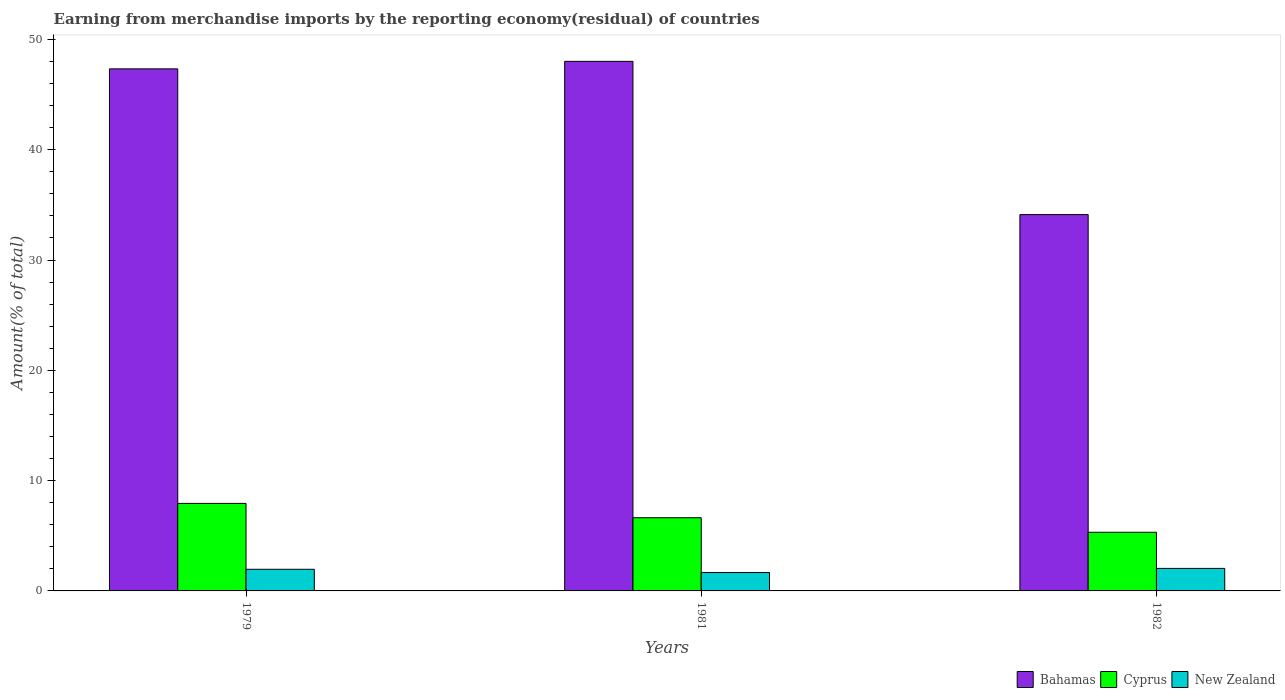How many different coloured bars are there?
Keep it short and to the point. 3. How many groups of bars are there?
Give a very brief answer. 3. How many bars are there on the 3rd tick from the left?
Your answer should be compact. 3. In how many cases, is the number of bars for a given year not equal to the number of legend labels?
Provide a short and direct response. 0. What is the percentage of amount earned from merchandise imports in Cyprus in 1979?
Offer a very short reply. 7.94. Across all years, what is the maximum percentage of amount earned from merchandise imports in Cyprus?
Keep it short and to the point. 7.94. Across all years, what is the minimum percentage of amount earned from merchandise imports in Cyprus?
Your answer should be compact. 5.32. In which year was the percentage of amount earned from merchandise imports in New Zealand maximum?
Offer a very short reply. 1982. What is the total percentage of amount earned from merchandise imports in New Zealand in the graph?
Offer a terse response. 5.67. What is the difference between the percentage of amount earned from merchandise imports in Cyprus in 1979 and that in 1981?
Your answer should be compact. 1.3. What is the difference between the percentage of amount earned from merchandise imports in New Zealand in 1981 and the percentage of amount earned from merchandise imports in Bahamas in 1979?
Your answer should be compact. -45.66. What is the average percentage of amount earned from merchandise imports in Bahamas per year?
Keep it short and to the point. 43.15. In the year 1982, what is the difference between the percentage of amount earned from merchandise imports in Cyprus and percentage of amount earned from merchandise imports in Bahamas?
Offer a very short reply. -28.8. What is the ratio of the percentage of amount earned from merchandise imports in New Zealand in 1979 to that in 1982?
Provide a short and direct response. 0.96. Is the difference between the percentage of amount earned from merchandise imports in Cyprus in 1981 and 1982 greater than the difference between the percentage of amount earned from merchandise imports in Bahamas in 1981 and 1982?
Give a very brief answer. No. What is the difference between the highest and the second highest percentage of amount earned from merchandise imports in New Zealand?
Your answer should be very brief. 0.08. What is the difference between the highest and the lowest percentage of amount earned from merchandise imports in New Zealand?
Make the answer very short. 0.37. In how many years, is the percentage of amount earned from merchandise imports in Bahamas greater than the average percentage of amount earned from merchandise imports in Bahamas taken over all years?
Your answer should be very brief. 2. Is the sum of the percentage of amount earned from merchandise imports in Cyprus in 1979 and 1981 greater than the maximum percentage of amount earned from merchandise imports in New Zealand across all years?
Ensure brevity in your answer.  Yes. What does the 1st bar from the left in 1979 represents?
Offer a terse response. Bahamas. What does the 1st bar from the right in 1982 represents?
Provide a succinct answer. New Zealand. Is it the case that in every year, the sum of the percentage of amount earned from merchandise imports in Cyprus and percentage of amount earned from merchandise imports in Bahamas is greater than the percentage of amount earned from merchandise imports in New Zealand?
Give a very brief answer. Yes. Are all the bars in the graph horizontal?
Your answer should be compact. No. What is the difference between two consecutive major ticks on the Y-axis?
Give a very brief answer. 10. Does the graph contain any zero values?
Give a very brief answer. No. Does the graph contain grids?
Your answer should be compact. No. How are the legend labels stacked?
Your response must be concise. Horizontal. What is the title of the graph?
Offer a very short reply. Earning from merchandise imports by the reporting economy(residual) of countries. Does "Middle East & North Africa (all income levels)" appear as one of the legend labels in the graph?
Your response must be concise. No. What is the label or title of the X-axis?
Ensure brevity in your answer.  Years. What is the label or title of the Y-axis?
Offer a very short reply. Amount(% of total). What is the Amount(% of total) in Bahamas in 1979?
Provide a succinct answer. 47.33. What is the Amount(% of total) in Cyprus in 1979?
Offer a terse response. 7.94. What is the Amount(% of total) of New Zealand in 1979?
Your answer should be very brief. 1.96. What is the Amount(% of total) of Bahamas in 1981?
Make the answer very short. 48.01. What is the Amount(% of total) in Cyprus in 1981?
Ensure brevity in your answer.  6.64. What is the Amount(% of total) of New Zealand in 1981?
Provide a succinct answer. 1.67. What is the Amount(% of total) of Bahamas in 1982?
Offer a terse response. 34.12. What is the Amount(% of total) in Cyprus in 1982?
Make the answer very short. 5.32. What is the Amount(% of total) in New Zealand in 1982?
Provide a succinct answer. 2.04. Across all years, what is the maximum Amount(% of total) of Bahamas?
Provide a short and direct response. 48.01. Across all years, what is the maximum Amount(% of total) of Cyprus?
Provide a short and direct response. 7.94. Across all years, what is the maximum Amount(% of total) of New Zealand?
Your answer should be very brief. 2.04. Across all years, what is the minimum Amount(% of total) of Bahamas?
Your answer should be compact. 34.12. Across all years, what is the minimum Amount(% of total) in Cyprus?
Give a very brief answer. 5.32. Across all years, what is the minimum Amount(% of total) in New Zealand?
Offer a very short reply. 1.67. What is the total Amount(% of total) of Bahamas in the graph?
Your response must be concise. 129.46. What is the total Amount(% of total) in Cyprus in the graph?
Your response must be concise. 19.89. What is the total Amount(% of total) of New Zealand in the graph?
Give a very brief answer. 5.67. What is the difference between the Amount(% of total) of Bahamas in 1979 and that in 1981?
Offer a very short reply. -0.68. What is the difference between the Amount(% of total) of Cyprus in 1979 and that in 1981?
Provide a succinct answer. 1.3. What is the difference between the Amount(% of total) of New Zealand in 1979 and that in 1981?
Keep it short and to the point. 0.29. What is the difference between the Amount(% of total) of Bahamas in 1979 and that in 1982?
Offer a terse response. 13.21. What is the difference between the Amount(% of total) of Cyprus in 1979 and that in 1982?
Provide a short and direct response. 2.62. What is the difference between the Amount(% of total) of New Zealand in 1979 and that in 1982?
Give a very brief answer. -0.08. What is the difference between the Amount(% of total) of Bahamas in 1981 and that in 1982?
Ensure brevity in your answer.  13.89. What is the difference between the Amount(% of total) in Cyprus in 1981 and that in 1982?
Make the answer very short. 1.32. What is the difference between the Amount(% of total) of New Zealand in 1981 and that in 1982?
Your response must be concise. -0.37. What is the difference between the Amount(% of total) of Bahamas in 1979 and the Amount(% of total) of Cyprus in 1981?
Your response must be concise. 40.69. What is the difference between the Amount(% of total) of Bahamas in 1979 and the Amount(% of total) of New Zealand in 1981?
Your answer should be very brief. 45.66. What is the difference between the Amount(% of total) in Cyprus in 1979 and the Amount(% of total) in New Zealand in 1981?
Offer a terse response. 6.26. What is the difference between the Amount(% of total) of Bahamas in 1979 and the Amount(% of total) of Cyprus in 1982?
Provide a short and direct response. 42.01. What is the difference between the Amount(% of total) of Bahamas in 1979 and the Amount(% of total) of New Zealand in 1982?
Your answer should be compact. 45.29. What is the difference between the Amount(% of total) of Cyprus in 1979 and the Amount(% of total) of New Zealand in 1982?
Offer a very short reply. 5.89. What is the difference between the Amount(% of total) of Bahamas in 1981 and the Amount(% of total) of Cyprus in 1982?
Your answer should be compact. 42.69. What is the difference between the Amount(% of total) of Bahamas in 1981 and the Amount(% of total) of New Zealand in 1982?
Provide a short and direct response. 45.97. What is the difference between the Amount(% of total) of Cyprus in 1981 and the Amount(% of total) of New Zealand in 1982?
Provide a succinct answer. 4.59. What is the average Amount(% of total) of Bahamas per year?
Your answer should be very brief. 43.15. What is the average Amount(% of total) of Cyprus per year?
Provide a succinct answer. 6.63. What is the average Amount(% of total) in New Zealand per year?
Offer a terse response. 1.89. In the year 1979, what is the difference between the Amount(% of total) of Bahamas and Amount(% of total) of Cyprus?
Keep it short and to the point. 39.4. In the year 1979, what is the difference between the Amount(% of total) of Bahamas and Amount(% of total) of New Zealand?
Provide a short and direct response. 45.37. In the year 1979, what is the difference between the Amount(% of total) of Cyprus and Amount(% of total) of New Zealand?
Offer a terse response. 5.97. In the year 1981, what is the difference between the Amount(% of total) in Bahamas and Amount(% of total) in Cyprus?
Offer a terse response. 41.38. In the year 1981, what is the difference between the Amount(% of total) in Bahamas and Amount(% of total) in New Zealand?
Provide a short and direct response. 46.34. In the year 1981, what is the difference between the Amount(% of total) of Cyprus and Amount(% of total) of New Zealand?
Your answer should be compact. 4.97. In the year 1982, what is the difference between the Amount(% of total) in Bahamas and Amount(% of total) in Cyprus?
Provide a succinct answer. 28.8. In the year 1982, what is the difference between the Amount(% of total) in Bahamas and Amount(% of total) in New Zealand?
Provide a short and direct response. 32.08. In the year 1982, what is the difference between the Amount(% of total) in Cyprus and Amount(% of total) in New Zealand?
Ensure brevity in your answer.  3.28. What is the ratio of the Amount(% of total) in Bahamas in 1979 to that in 1981?
Offer a terse response. 0.99. What is the ratio of the Amount(% of total) in Cyprus in 1979 to that in 1981?
Provide a succinct answer. 1.2. What is the ratio of the Amount(% of total) in New Zealand in 1979 to that in 1981?
Offer a very short reply. 1.17. What is the ratio of the Amount(% of total) in Bahamas in 1979 to that in 1982?
Make the answer very short. 1.39. What is the ratio of the Amount(% of total) of Cyprus in 1979 to that in 1982?
Your answer should be very brief. 1.49. What is the ratio of the Amount(% of total) in New Zealand in 1979 to that in 1982?
Provide a succinct answer. 0.96. What is the ratio of the Amount(% of total) in Bahamas in 1981 to that in 1982?
Your response must be concise. 1.41. What is the ratio of the Amount(% of total) of Cyprus in 1981 to that in 1982?
Make the answer very short. 1.25. What is the ratio of the Amount(% of total) of New Zealand in 1981 to that in 1982?
Give a very brief answer. 0.82. What is the difference between the highest and the second highest Amount(% of total) of Bahamas?
Give a very brief answer. 0.68. What is the difference between the highest and the second highest Amount(% of total) of Cyprus?
Make the answer very short. 1.3. What is the difference between the highest and the second highest Amount(% of total) in New Zealand?
Your response must be concise. 0.08. What is the difference between the highest and the lowest Amount(% of total) of Bahamas?
Provide a succinct answer. 13.89. What is the difference between the highest and the lowest Amount(% of total) of Cyprus?
Offer a very short reply. 2.62. What is the difference between the highest and the lowest Amount(% of total) of New Zealand?
Provide a short and direct response. 0.37. 